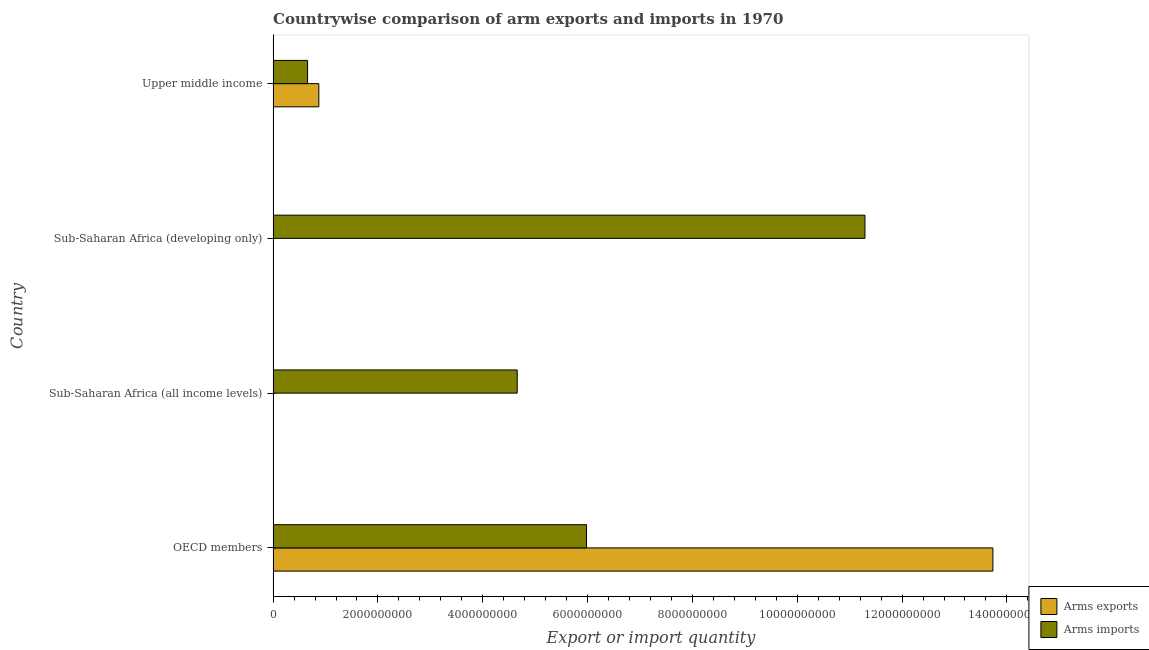Are the number of bars per tick equal to the number of legend labels?
Make the answer very short. Yes. How many bars are there on the 3rd tick from the bottom?
Your response must be concise. 2. What is the label of the 2nd group of bars from the top?
Give a very brief answer. Sub-Saharan Africa (developing only). What is the arms imports in Sub-Saharan Africa (developing only)?
Give a very brief answer. 1.13e+1. Across all countries, what is the maximum arms imports?
Your answer should be very brief. 1.13e+1. Across all countries, what is the minimum arms exports?
Give a very brief answer. 3.00e+06. In which country was the arms exports maximum?
Provide a short and direct response. OECD members. In which country was the arms imports minimum?
Ensure brevity in your answer.  Upper middle income. What is the total arms imports in the graph?
Your answer should be compact. 2.26e+1. What is the difference between the arms imports in Sub-Saharan Africa (all income levels) and that in Sub-Saharan Africa (developing only)?
Provide a short and direct response. -6.64e+09. What is the difference between the arms imports in Sub-Saharan Africa (all income levels) and the arms exports in Upper middle income?
Keep it short and to the point. 3.78e+09. What is the average arms imports per country?
Keep it short and to the point. 5.65e+09. What is the difference between the arms exports and arms imports in Upper middle income?
Ensure brevity in your answer.  2.15e+08. What is the ratio of the arms exports in OECD members to that in Upper middle income?
Provide a succinct answer. 15.75. Is the arms exports in Sub-Saharan Africa (developing only) less than that in Upper middle income?
Provide a short and direct response. Yes. Is the difference between the arms exports in OECD members and Sub-Saharan Africa (all income levels) greater than the difference between the arms imports in OECD members and Sub-Saharan Africa (all income levels)?
Provide a short and direct response. Yes. What is the difference between the highest and the second highest arms imports?
Keep it short and to the point. 5.31e+09. What is the difference between the highest and the lowest arms exports?
Provide a succinct answer. 1.37e+1. In how many countries, is the arms exports greater than the average arms exports taken over all countries?
Provide a succinct answer. 1. What does the 2nd bar from the top in Upper middle income represents?
Offer a terse response. Arms exports. What does the 1st bar from the bottom in Sub-Saharan Africa (all income levels) represents?
Your answer should be compact. Arms exports. Are all the bars in the graph horizontal?
Offer a very short reply. Yes. How many countries are there in the graph?
Provide a short and direct response. 4. Are the values on the major ticks of X-axis written in scientific E-notation?
Keep it short and to the point. No. Does the graph contain any zero values?
Your answer should be compact. No. Does the graph contain grids?
Provide a short and direct response. No. Where does the legend appear in the graph?
Your answer should be compact. Bottom right. How many legend labels are there?
Provide a short and direct response. 2. What is the title of the graph?
Keep it short and to the point. Countrywise comparison of arm exports and imports in 1970. What is the label or title of the X-axis?
Provide a succinct answer. Export or import quantity. What is the label or title of the Y-axis?
Offer a terse response. Country. What is the Export or import quantity in Arms exports in OECD members?
Give a very brief answer. 1.37e+1. What is the Export or import quantity in Arms imports in OECD members?
Make the answer very short. 5.98e+09. What is the Export or import quantity of Arms imports in Sub-Saharan Africa (all income levels)?
Provide a short and direct response. 4.66e+09. What is the Export or import quantity of Arms exports in Sub-Saharan Africa (developing only)?
Ensure brevity in your answer.  3.00e+06. What is the Export or import quantity of Arms imports in Sub-Saharan Africa (developing only)?
Make the answer very short. 1.13e+1. What is the Export or import quantity of Arms exports in Upper middle income?
Your answer should be compact. 8.72e+08. What is the Export or import quantity of Arms imports in Upper middle income?
Make the answer very short. 6.57e+08. Across all countries, what is the maximum Export or import quantity in Arms exports?
Make the answer very short. 1.37e+1. Across all countries, what is the maximum Export or import quantity in Arms imports?
Keep it short and to the point. 1.13e+1. Across all countries, what is the minimum Export or import quantity in Arms imports?
Make the answer very short. 6.57e+08. What is the total Export or import quantity of Arms exports in the graph?
Your answer should be compact. 1.46e+1. What is the total Export or import quantity of Arms imports in the graph?
Ensure brevity in your answer.  2.26e+1. What is the difference between the Export or import quantity in Arms exports in OECD members and that in Sub-Saharan Africa (all income levels)?
Your answer should be compact. 1.37e+1. What is the difference between the Export or import quantity in Arms imports in OECD members and that in Sub-Saharan Africa (all income levels)?
Your response must be concise. 1.32e+09. What is the difference between the Export or import quantity of Arms exports in OECD members and that in Sub-Saharan Africa (developing only)?
Offer a terse response. 1.37e+1. What is the difference between the Export or import quantity in Arms imports in OECD members and that in Sub-Saharan Africa (developing only)?
Offer a very short reply. -5.31e+09. What is the difference between the Export or import quantity in Arms exports in OECD members and that in Upper middle income?
Offer a very short reply. 1.29e+1. What is the difference between the Export or import quantity in Arms imports in OECD members and that in Upper middle income?
Your answer should be compact. 5.32e+09. What is the difference between the Export or import quantity of Arms imports in Sub-Saharan Africa (all income levels) and that in Sub-Saharan Africa (developing only)?
Your answer should be compact. -6.64e+09. What is the difference between the Export or import quantity of Arms exports in Sub-Saharan Africa (all income levels) and that in Upper middle income?
Offer a very short reply. -8.69e+08. What is the difference between the Export or import quantity in Arms imports in Sub-Saharan Africa (all income levels) and that in Upper middle income?
Make the answer very short. 4.00e+09. What is the difference between the Export or import quantity in Arms exports in Sub-Saharan Africa (developing only) and that in Upper middle income?
Provide a short and direct response. -8.69e+08. What is the difference between the Export or import quantity of Arms imports in Sub-Saharan Africa (developing only) and that in Upper middle income?
Your response must be concise. 1.06e+1. What is the difference between the Export or import quantity in Arms exports in OECD members and the Export or import quantity in Arms imports in Sub-Saharan Africa (all income levels)?
Offer a very short reply. 9.08e+09. What is the difference between the Export or import quantity of Arms exports in OECD members and the Export or import quantity of Arms imports in Sub-Saharan Africa (developing only)?
Ensure brevity in your answer.  2.44e+09. What is the difference between the Export or import quantity in Arms exports in OECD members and the Export or import quantity in Arms imports in Upper middle income?
Ensure brevity in your answer.  1.31e+1. What is the difference between the Export or import quantity in Arms exports in Sub-Saharan Africa (all income levels) and the Export or import quantity in Arms imports in Sub-Saharan Africa (developing only)?
Your answer should be very brief. -1.13e+1. What is the difference between the Export or import quantity in Arms exports in Sub-Saharan Africa (all income levels) and the Export or import quantity in Arms imports in Upper middle income?
Your response must be concise. -6.54e+08. What is the difference between the Export or import quantity in Arms exports in Sub-Saharan Africa (developing only) and the Export or import quantity in Arms imports in Upper middle income?
Ensure brevity in your answer.  -6.54e+08. What is the average Export or import quantity in Arms exports per country?
Your answer should be very brief. 3.65e+09. What is the average Export or import quantity of Arms imports per country?
Keep it short and to the point. 5.65e+09. What is the difference between the Export or import quantity in Arms exports and Export or import quantity in Arms imports in OECD members?
Your response must be concise. 7.75e+09. What is the difference between the Export or import quantity of Arms exports and Export or import quantity of Arms imports in Sub-Saharan Africa (all income levels)?
Provide a succinct answer. -4.65e+09. What is the difference between the Export or import quantity in Arms exports and Export or import quantity in Arms imports in Sub-Saharan Africa (developing only)?
Keep it short and to the point. -1.13e+1. What is the difference between the Export or import quantity of Arms exports and Export or import quantity of Arms imports in Upper middle income?
Your answer should be very brief. 2.15e+08. What is the ratio of the Export or import quantity in Arms exports in OECD members to that in Sub-Saharan Africa (all income levels)?
Offer a very short reply. 4577.67. What is the ratio of the Export or import quantity of Arms imports in OECD members to that in Sub-Saharan Africa (all income levels)?
Keep it short and to the point. 1.28. What is the ratio of the Export or import quantity of Arms exports in OECD members to that in Sub-Saharan Africa (developing only)?
Provide a short and direct response. 4577.67. What is the ratio of the Export or import quantity in Arms imports in OECD members to that in Sub-Saharan Africa (developing only)?
Offer a terse response. 0.53. What is the ratio of the Export or import quantity in Arms exports in OECD members to that in Upper middle income?
Your answer should be very brief. 15.75. What is the ratio of the Export or import quantity in Arms imports in OECD members to that in Upper middle income?
Your response must be concise. 9.1. What is the ratio of the Export or import quantity of Arms imports in Sub-Saharan Africa (all income levels) to that in Sub-Saharan Africa (developing only)?
Provide a short and direct response. 0.41. What is the ratio of the Export or import quantity of Arms exports in Sub-Saharan Africa (all income levels) to that in Upper middle income?
Ensure brevity in your answer.  0. What is the ratio of the Export or import quantity in Arms imports in Sub-Saharan Africa (all income levels) to that in Upper middle income?
Make the answer very short. 7.09. What is the ratio of the Export or import quantity in Arms exports in Sub-Saharan Africa (developing only) to that in Upper middle income?
Provide a short and direct response. 0. What is the ratio of the Export or import quantity in Arms imports in Sub-Saharan Africa (developing only) to that in Upper middle income?
Offer a very short reply. 17.19. What is the difference between the highest and the second highest Export or import quantity of Arms exports?
Keep it short and to the point. 1.29e+1. What is the difference between the highest and the second highest Export or import quantity of Arms imports?
Provide a short and direct response. 5.31e+09. What is the difference between the highest and the lowest Export or import quantity in Arms exports?
Offer a terse response. 1.37e+1. What is the difference between the highest and the lowest Export or import quantity of Arms imports?
Make the answer very short. 1.06e+1. 